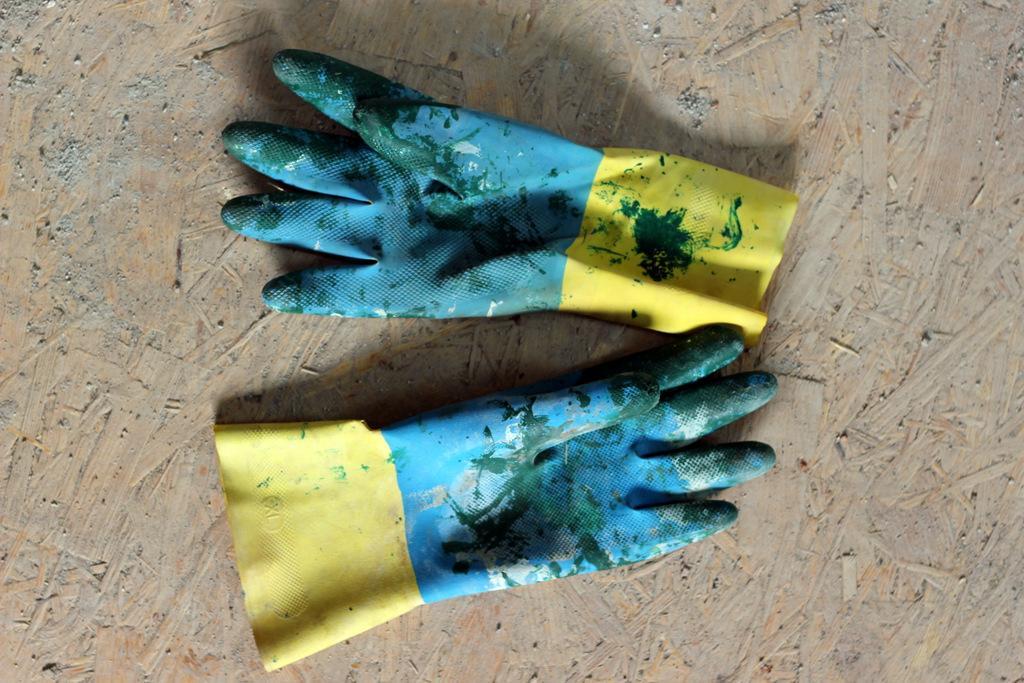Could you give a brief overview of what you see in this image? In this image two gloves are kept on the floor. 